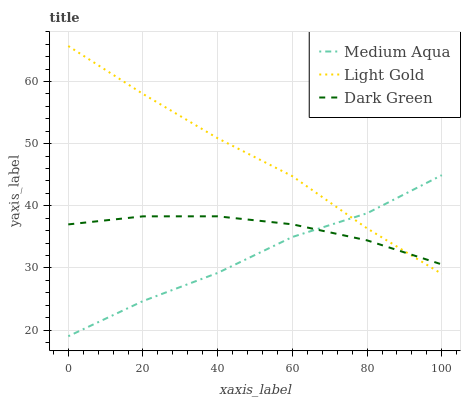Does Medium Aqua have the minimum area under the curve?
Answer yes or no. Yes. Does Light Gold have the maximum area under the curve?
Answer yes or no. Yes. Does Dark Green have the minimum area under the curve?
Answer yes or no. No. Does Dark Green have the maximum area under the curve?
Answer yes or no. No. Is Light Gold the smoothest?
Answer yes or no. Yes. Is Medium Aqua the roughest?
Answer yes or no. Yes. Is Dark Green the smoothest?
Answer yes or no. No. Is Dark Green the roughest?
Answer yes or no. No. Does Medium Aqua have the lowest value?
Answer yes or no. Yes. Does Dark Green have the lowest value?
Answer yes or no. No. Does Light Gold have the highest value?
Answer yes or no. Yes. Does Medium Aqua have the highest value?
Answer yes or no. No. Does Medium Aqua intersect Dark Green?
Answer yes or no. Yes. Is Medium Aqua less than Dark Green?
Answer yes or no. No. Is Medium Aqua greater than Dark Green?
Answer yes or no. No. 